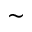Convert formula to latex. <formula><loc_0><loc_0><loc_500><loc_500>\sim</formula> 